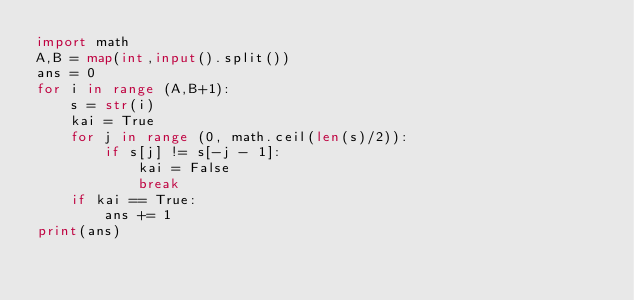Convert code to text. <code><loc_0><loc_0><loc_500><loc_500><_Python_>import math
A,B = map(int,input().split())
ans = 0
for i in range (A,B+1):
    s = str(i)
    kai = True
    for j in range (0, math.ceil(len(s)/2)):
        if s[j] != s[-j - 1]:
            kai = False
            break
    if kai == True:
        ans += 1
print(ans)</code> 